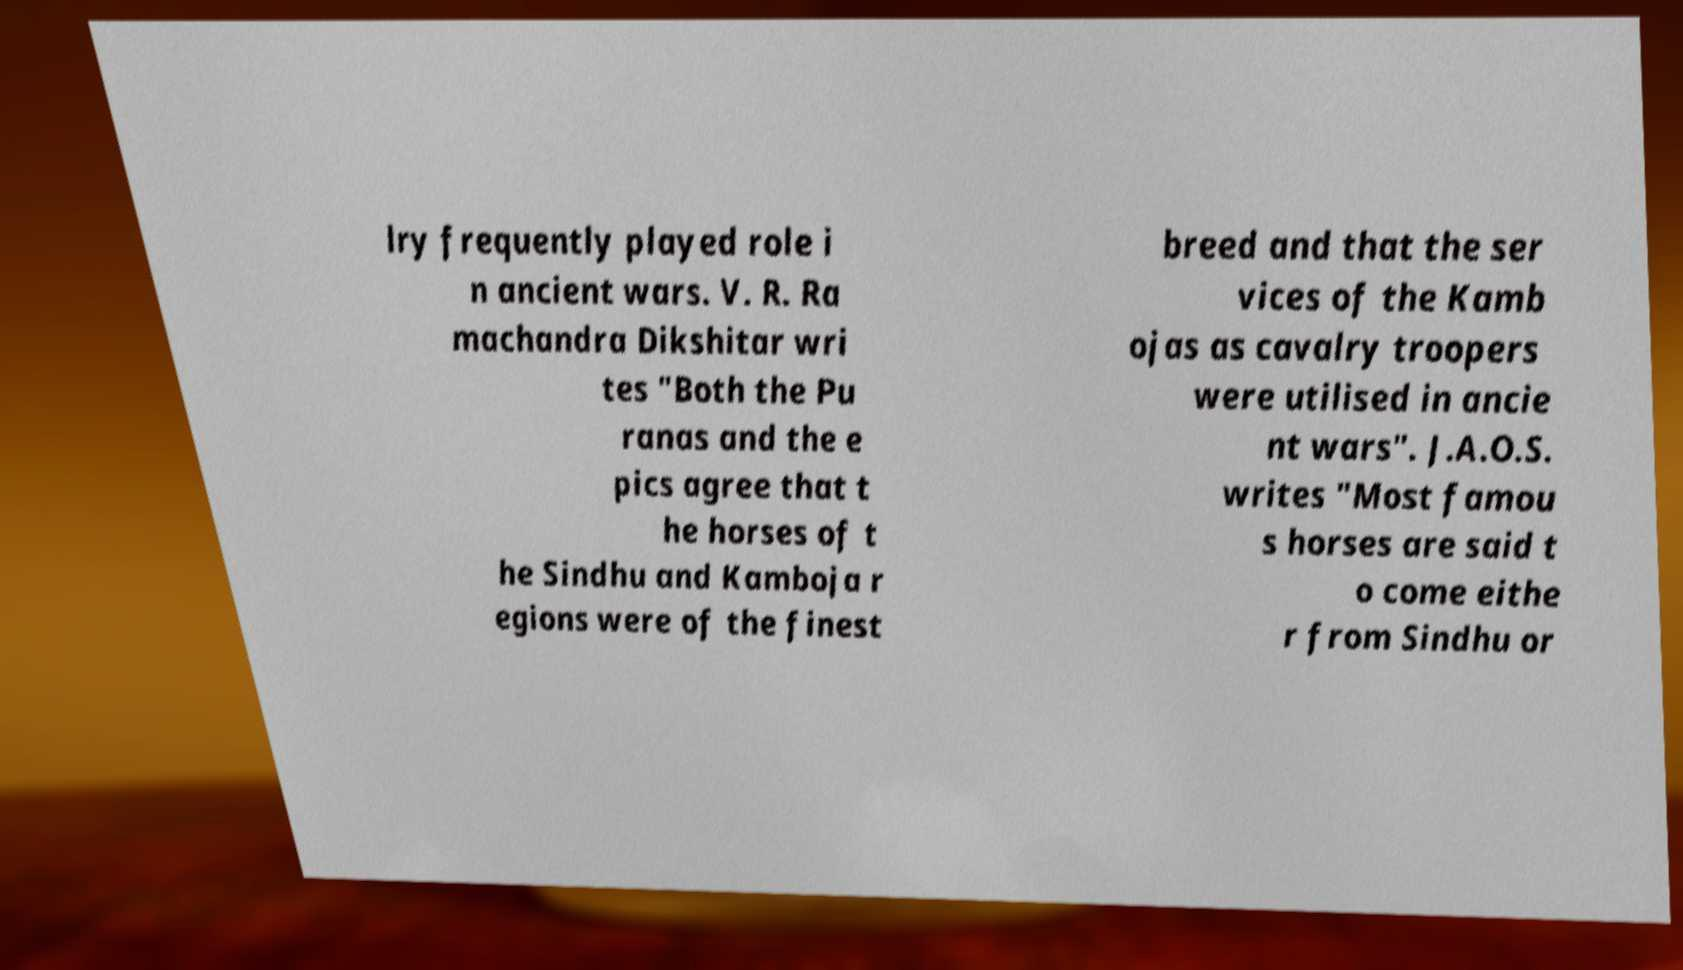Can you accurately transcribe the text from the provided image for me? lry frequently played role i n ancient wars. V. R. Ra machandra Dikshitar wri tes "Both the Pu ranas and the e pics agree that t he horses of t he Sindhu and Kamboja r egions were of the finest breed and that the ser vices of the Kamb ojas as cavalry troopers were utilised in ancie nt wars". J.A.O.S. writes "Most famou s horses are said t o come eithe r from Sindhu or 